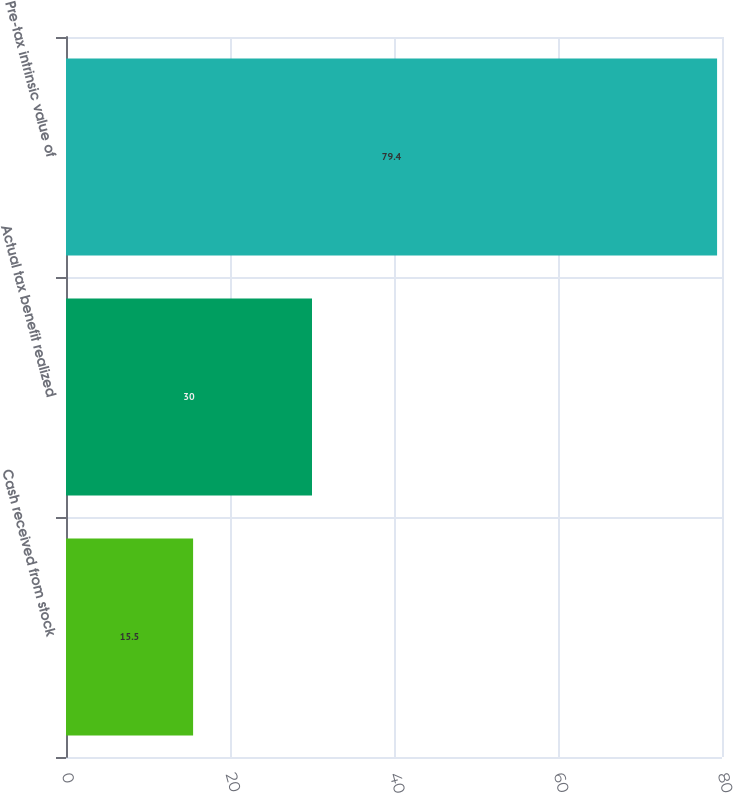<chart> <loc_0><loc_0><loc_500><loc_500><bar_chart><fcel>Cash received from stock<fcel>Actual tax benefit realized<fcel>Pre-tax intrinsic value of<nl><fcel>15.5<fcel>30<fcel>79.4<nl></chart> 